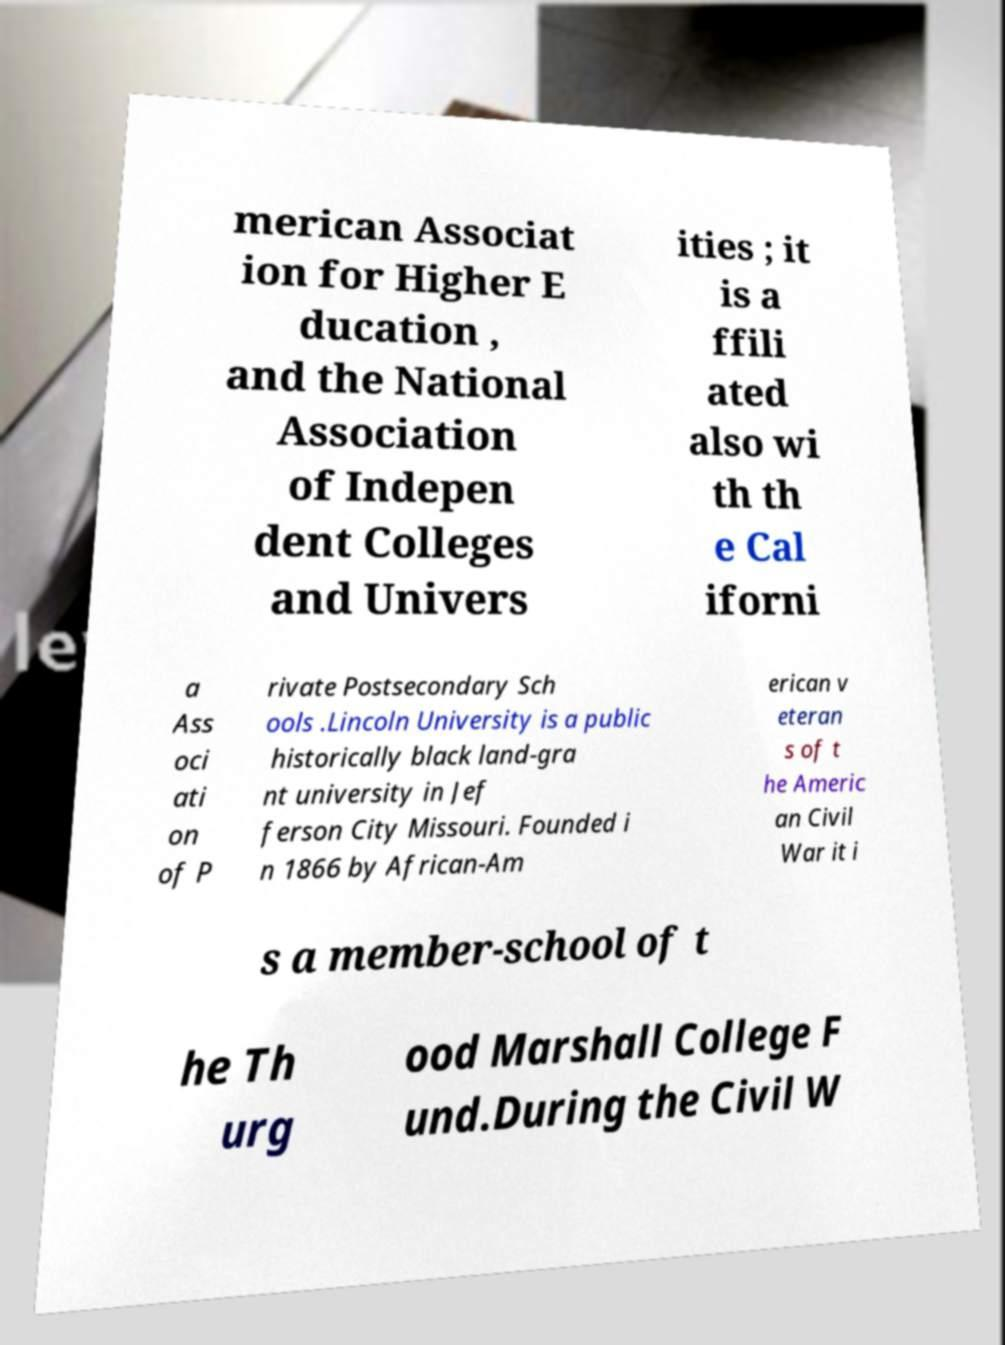Please read and relay the text visible in this image. What does it say? merican Associat ion for Higher E ducation , and the National Association of Indepen dent Colleges and Univers ities ; it is a ffili ated also wi th th e Cal iforni a Ass oci ati on of P rivate Postsecondary Sch ools .Lincoln University is a public historically black land-gra nt university in Jef ferson City Missouri. Founded i n 1866 by African-Am erican v eteran s of t he Americ an Civil War it i s a member-school of t he Th urg ood Marshall College F und.During the Civil W 